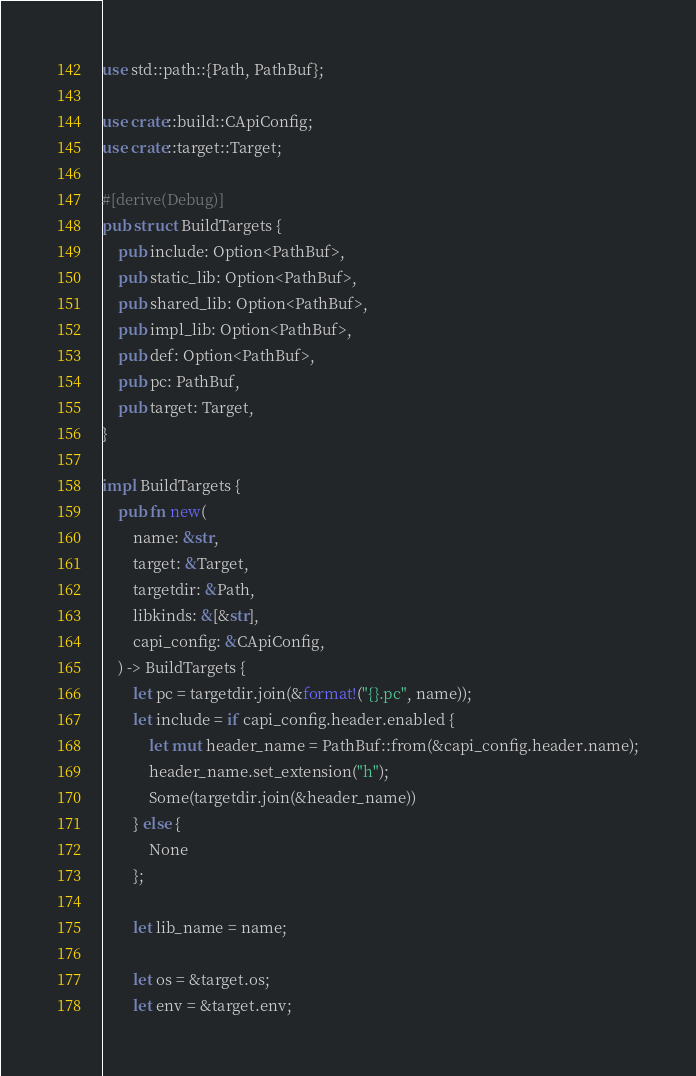Convert code to text. <code><loc_0><loc_0><loc_500><loc_500><_Rust_>use std::path::{Path, PathBuf};

use crate::build::CApiConfig;
use crate::target::Target;

#[derive(Debug)]
pub struct BuildTargets {
    pub include: Option<PathBuf>,
    pub static_lib: Option<PathBuf>,
    pub shared_lib: Option<PathBuf>,
    pub impl_lib: Option<PathBuf>,
    pub def: Option<PathBuf>,
    pub pc: PathBuf,
    pub target: Target,
}

impl BuildTargets {
    pub fn new(
        name: &str,
        target: &Target,
        targetdir: &Path,
        libkinds: &[&str],
        capi_config: &CApiConfig,
    ) -> BuildTargets {
        let pc = targetdir.join(&format!("{}.pc", name));
        let include = if capi_config.header.enabled {
            let mut header_name = PathBuf::from(&capi_config.header.name);
            header_name.set_extension("h");
            Some(targetdir.join(&header_name))
        } else {
            None
        };

        let lib_name = name;

        let os = &target.os;
        let env = &target.env;
</code> 